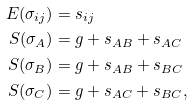Convert formula to latex. <formula><loc_0><loc_0><loc_500><loc_500>E ( \sigma _ { i j } ) & = s _ { i j } \\ S ( \sigma _ { A } ) & = g + s _ { A B } + s _ { A C } \\ S ( \sigma _ { B } ) & = g + s _ { A B } + s _ { B C } \\ S ( \sigma _ { C } ) & = g + s _ { A C } + s _ { B C } ,</formula> 